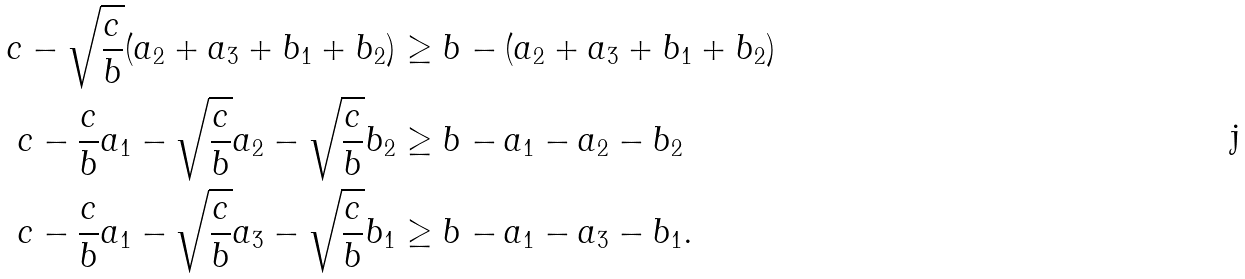Convert formula to latex. <formula><loc_0><loc_0><loc_500><loc_500>c - \sqrt { \frac { c } { b } } ( a _ { 2 } + a _ { 3 } + b _ { 1 } + b _ { 2 } ) & \geq b - ( a _ { 2 } + a _ { 3 } + b _ { 1 } + b _ { 2 } ) \\ c - \frac { c } { b } a _ { 1 } - \sqrt { \frac { c } { b } } a _ { 2 } - \sqrt { \frac { c } { b } } b _ { 2 } & \geq b - a _ { 1 } - a _ { 2 } - b _ { 2 } \\ c - \frac { c } { b } a _ { 1 } - \sqrt { \frac { c } { b } } a _ { 3 } - \sqrt { \frac { c } { b } } b _ { 1 } & \geq b - a _ { 1 } - a _ { 3 } - b _ { 1 } .</formula> 